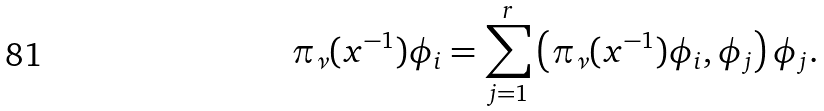Convert formula to latex. <formula><loc_0><loc_0><loc_500><loc_500>\pi _ { \nu } ( x ^ { - 1 } ) \phi _ { i } = \sum _ { j = 1 } ^ { r } \left ( \pi _ { \nu } ( x ^ { - 1 } ) \phi _ { i } , \phi _ { j } \right ) \phi _ { j } .</formula> 